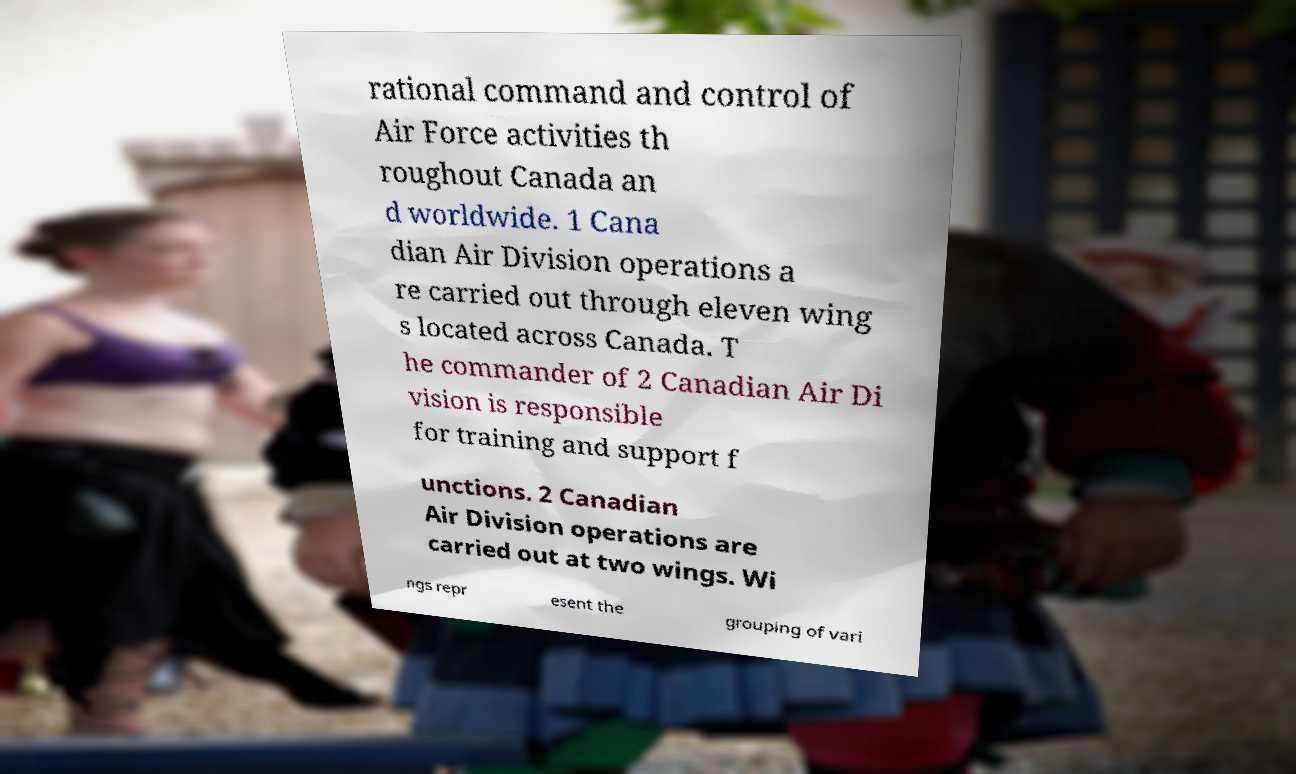I need the written content from this picture converted into text. Can you do that? rational command and control of Air Force activities th roughout Canada an d worldwide. 1 Cana dian Air Division operations a re carried out through eleven wing s located across Canada. T he commander of 2 Canadian Air Di vision is responsible for training and support f unctions. 2 Canadian Air Division operations are carried out at two wings. Wi ngs repr esent the grouping of vari 